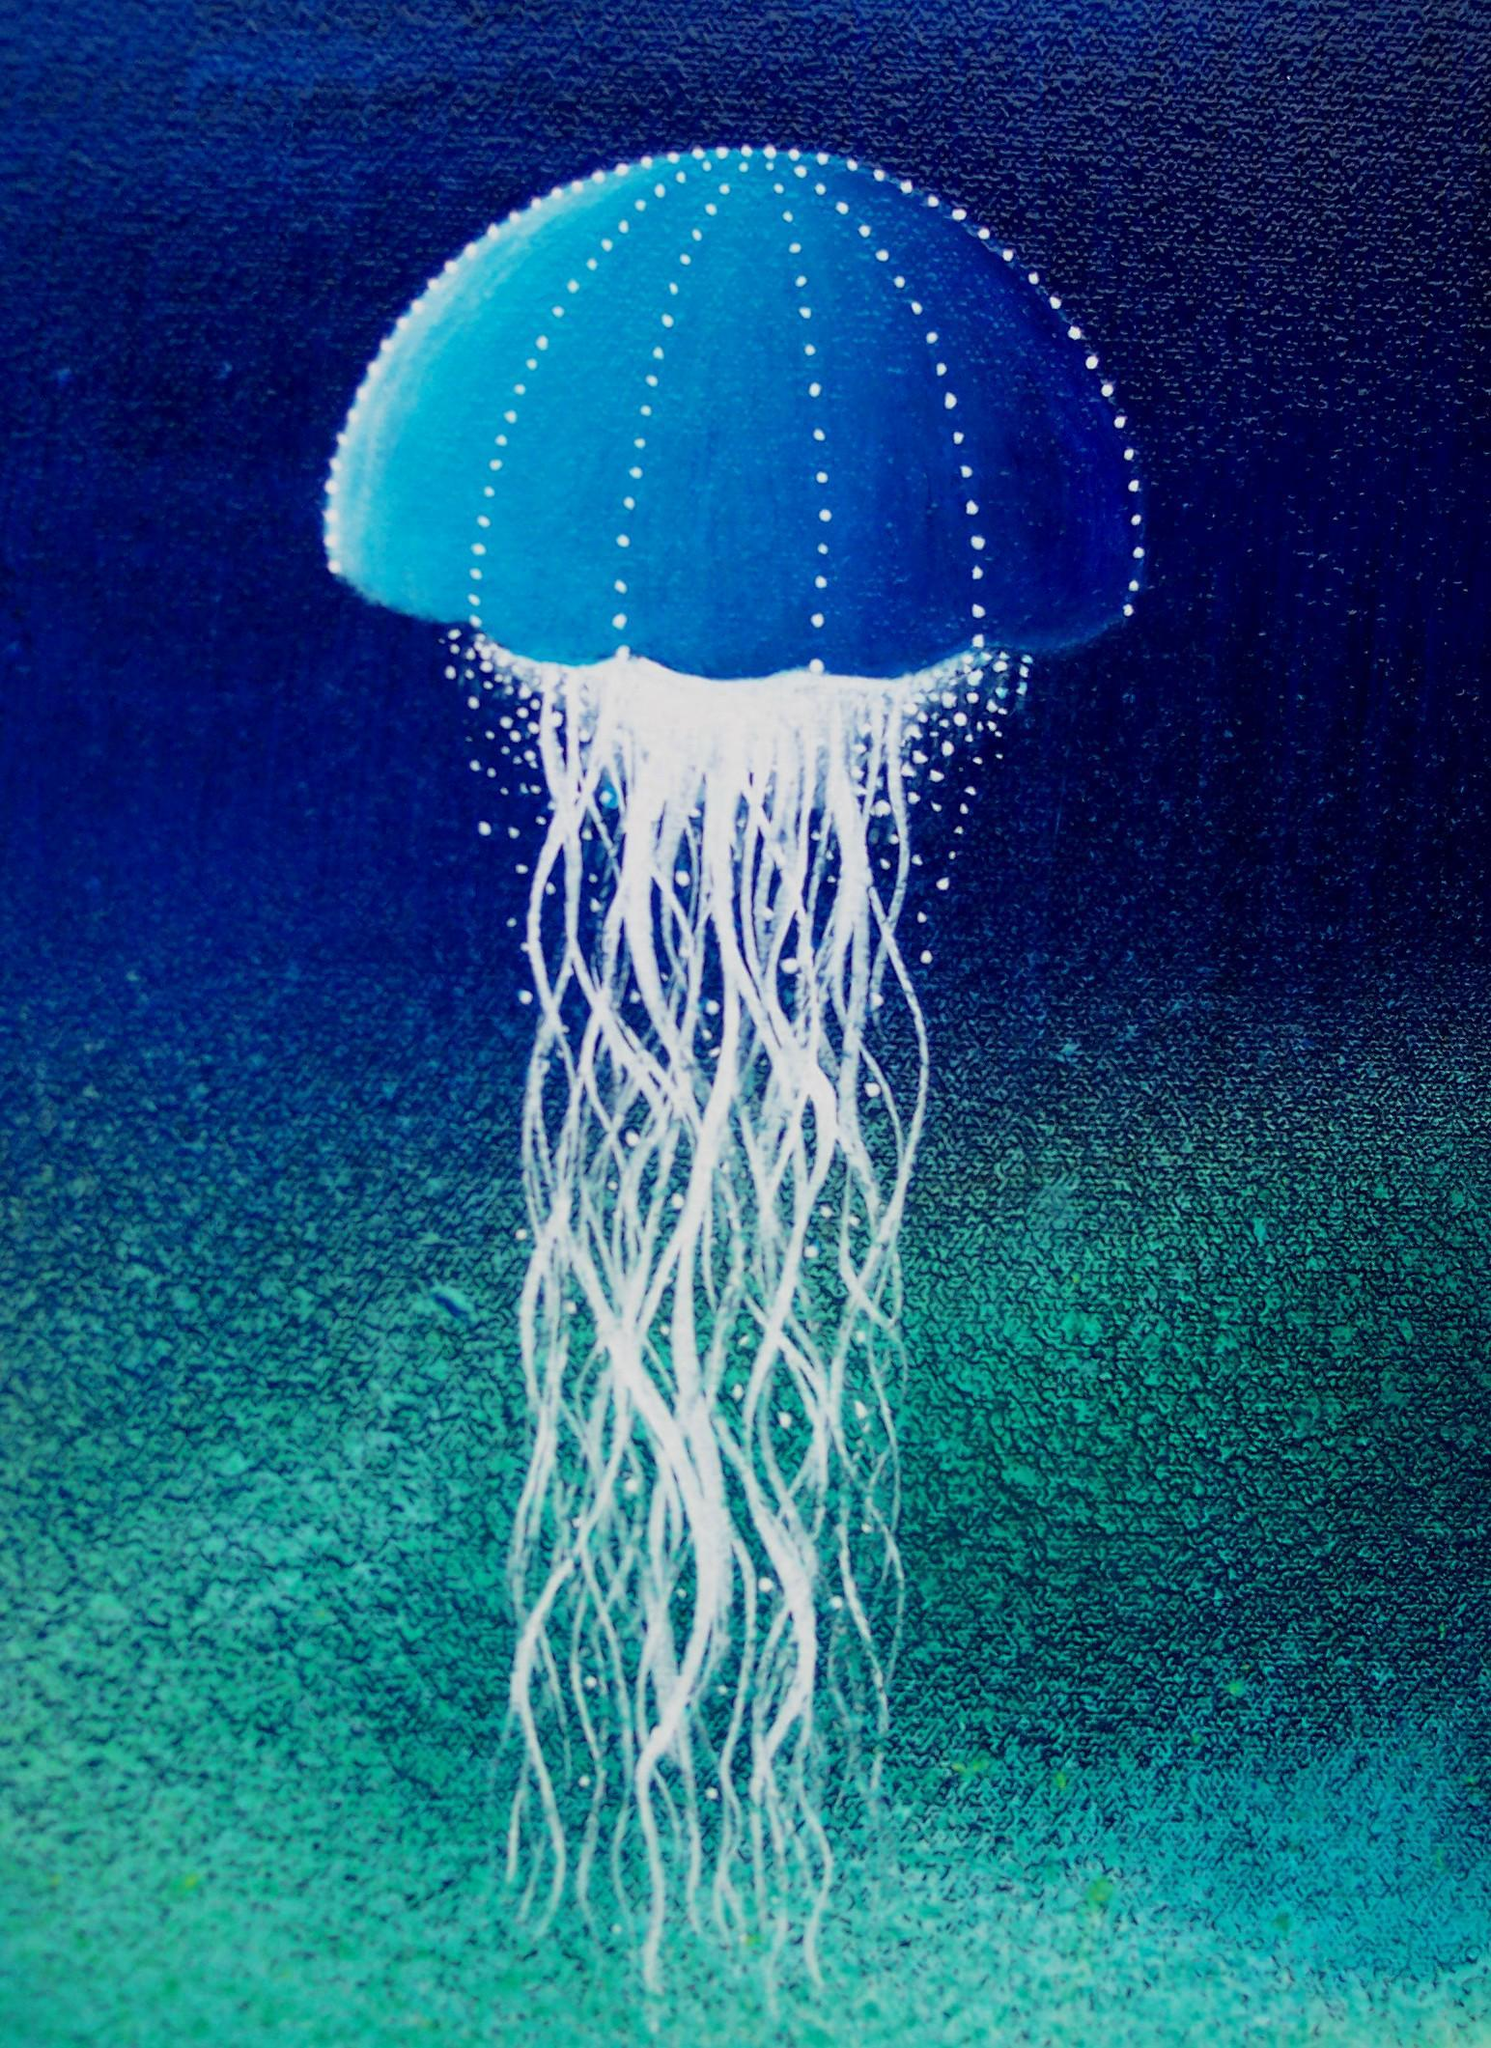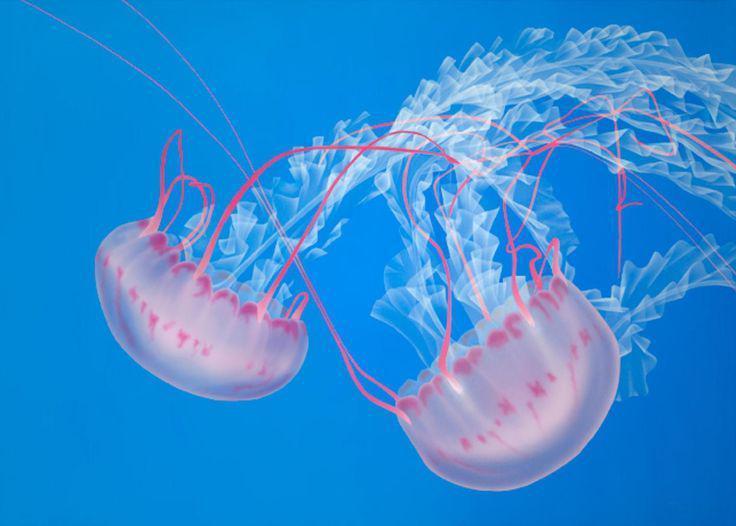The first image is the image on the left, the second image is the image on the right. Examine the images to the left and right. Is the description "There are pale pink jellyfish with a clear blue background" accurate? Answer yes or no. Yes. 